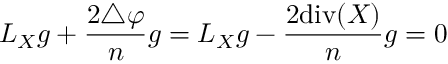<formula> <loc_0><loc_0><loc_500><loc_500>L _ { X } g + { \frac { 2 \triangle \varphi } { n } } g = L _ { X } g - { \frac { 2 d i v ( X ) } { n } } g = 0</formula> 